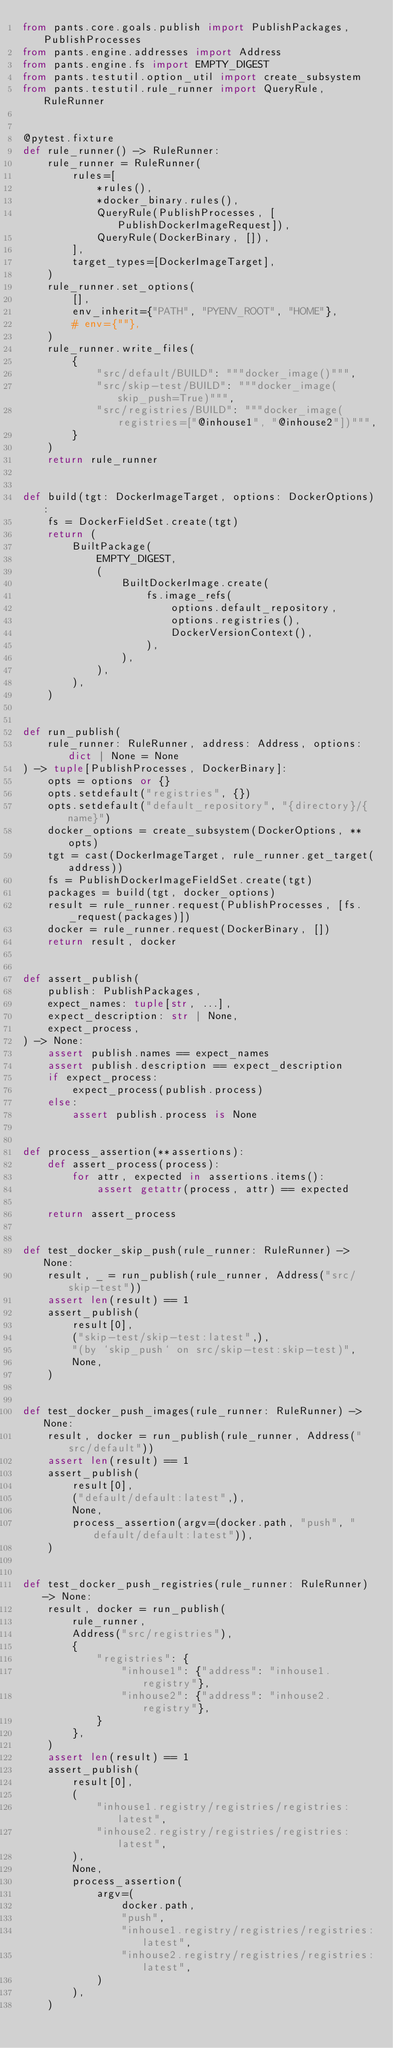<code> <loc_0><loc_0><loc_500><loc_500><_Python_>from pants.core.goals.publish import PublishPackages, PublishProcesses
from pants.engine.addresses import Address
from pants.engine.fs import EMPTY_DIGEST
from pants.testutil.option_util import create_subsystem
from pants.testutil.rule_runner import QueryRule, RuleRunner


@pytest.fixture
def rule_runner() -> RuleRunner:
    rule_runner = RuleRunner(
        rules=[
            *rules(),
            *docker_binary.rules(),
            QueryRule(PublishProcesses, [PublishDockerImageRequest]),
            QueryRule(DockerBinary, []),
        ],
        target_types=[DockerImageTarget],
    )
    rule_runner.set_options(
        [],
        env_inherit={"PATH", "PYENV_ROOT", "HOME"},
        # env={""},
    )
    rule_runner.write_files(
        {
            "src/default/BUILD": """docker_image()""",
            "src/skip-test/BUILD": """docker_image(skip_push=True)""",
            "src/registries/BUILD": """docker_image(registries=["@inhouse1", "@inhouse2"])""",
        }
    )
    return rule_runner


def build(tgt: DockerImageTarget, options: DockerOptions):
    fs = DockerFieldSet.create(tgt)
    return (
        BuiltPackage(
            EMPTY_DIGEST,
            (
                BuiltDockerImage.create(
                    fs.image_refs(
                        options.default_repository,
                        options.registries(),
                        DockerVersionContext(),
                    ),
                ),
            ),
        ),
    )


def run_publish(
    rule_runner: RuleRunner, address: Address, options: dict | None = None
) -> tuple[PublishProcesses, DockerBinary]:
    opts = options or {}
    opts.setdefault("registries", {})
    opts.setdefault("default_repository", "{directory}/{name}")
    docker_options = create_subsystem(DockerOptions, **opts)
    tgt = cast(DockerImageTarget, rule_runner.get_target(address))
    fs = PublishDockerImageFieldSet.create(tgt)
    packages = build(tgt, docker_options)
    result = rule_runner.request(PublishProcesses, [fs._request(packages)])
    docker = rule_runner.request(DockerBinary, [])
    return result, docker


def assert_publish(
    publish: PublishPackages,
    expect_names: tuple[str, ...],
    expect_description: str | None,
    expect_process,
) -> None:
    assert publish.names == expect_names
    assert publish.description == expect_description
    if expect_process:
        expect_process(publish.process)
    else:
        assert publish.process is None


def process_assertion(**assertions):
    def assert_process(process):
        for attr, expected in assertions.items():
            assert getattr(process, attr) == expected

    return assert_process


def test_docker_skip_push(rule_runner: RuleRunner) -> None:
    result, _ = run_publish(rule_runner, Address("src/skip-test"))
    assert len(result) == 1
    assert_publish(
        result[0],
        ("skip-test/skip-test:latest",),
        "(by `skip_push` on src/skip-test:skip-test)",
        None,
    )


def test_docker_push_images(rule_runner: RuleRunner) -> None:
    result, docker = run_publish(rule_runner, Address("src/default"))
    assert len(result) == 1
    assert_publish(
        result[0],
        ("default/default:latest",),
        None,
        process_assertion(argv=(docker.path, "push", "default/default:latest")),
    )


def test_docker_push_registries(rule_runner: RuleRunner) -> None:
    result, docker = run_publish(
        rule_runner,
        Address("src/registries"),
        {
            "registries": {
                "inhouse1": {"address": "inhouse1.registry"},
                "inhouse2": {"address": "inhouse2.registry"},
            }
        },
    )
    assert len(result) == 1
    assert_publish(
        result[0],
        (
            "inhouse1.registry/registries/registries:latest",
            "inhouse2.registry/registries/registries:latest",
        ),
        None,
        process_assertion(
            argv=(
                docker.path,
                "push",
                "inhouse1.registry/registries/registries:latest",
                "inhouse2.registry/registries/registries:latest",
            )
        ),
    )
</code> 